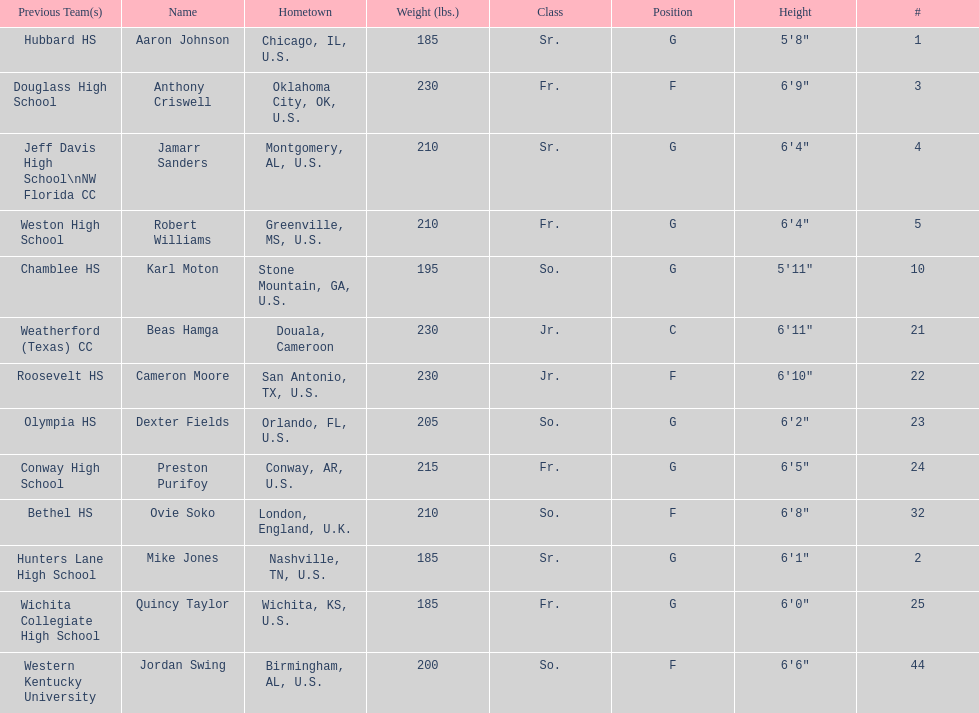Who weighs more, dexter fields or ovie soko? Ovie Soko. 